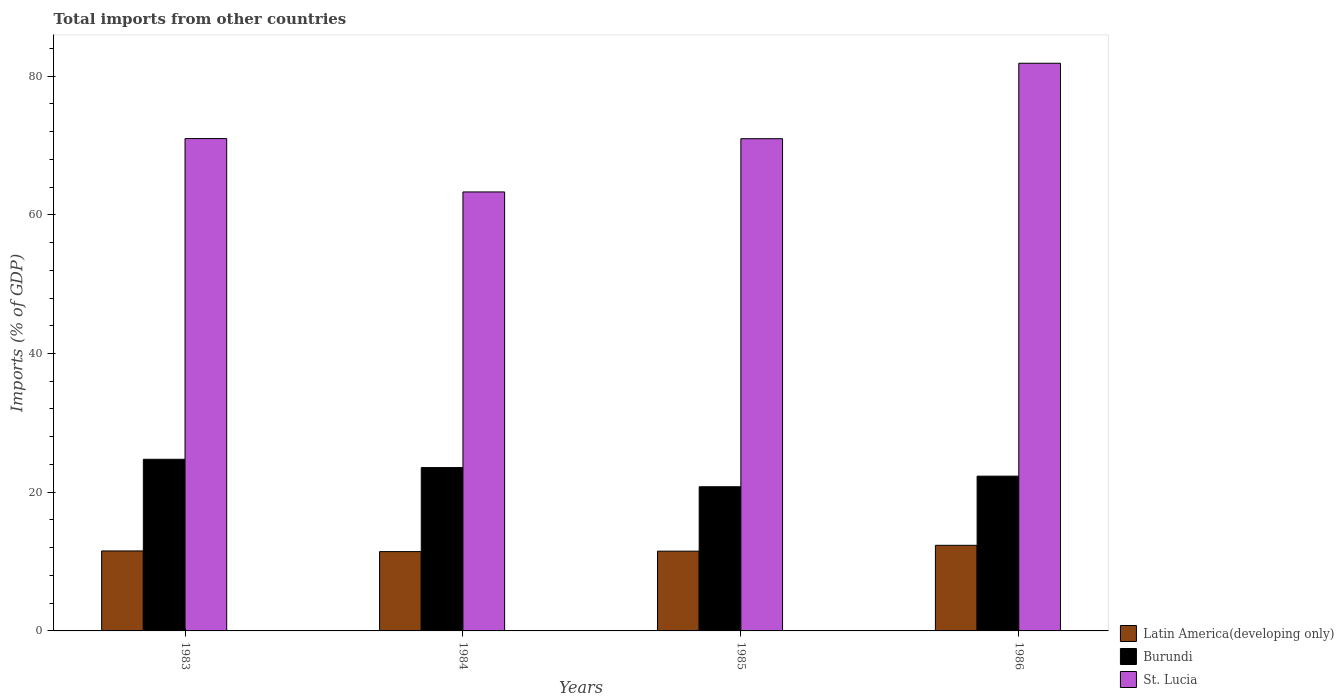Are the number of bars per tick equal to the number of legend labels?
Your answer should be compact. Yes. Are the number of bars on each tick of the X-axis equal?
Provide a succinct answer. Yes. How many bars are there on the 3rd tick from the left?
Provide a short and direct response. 3. In how many cases, is the number of bars for a given year not equal to the number of legend labels?
Ensure brevity in your answer.  0. What is the total imports in Latin America(developing only) in 1984?
Give a very brief answer. 11.44. Across all years, what is the maximum total imports in Burundi?
Your response must be concise. 24.75. Across all years, what is the minimum total imports in St. Lucia?
Ensure brevity in your answer.  63.3. In which year was the total imports in Burundi maximum?
Offer a very short reply. 1983. What is the total total imports in St. Lucia in the graph?
Keep it short and to the point. 287.11. What is the difference between the total imports in Latin America(developing only) in 1983 and that in 1986?
Your answer should be compact. -0.81. What is the difference between the total imports in Latin America(developing only) in 1986 and the total imports in St. Lucia in 1984?
Provide a short and direct response. -50.95. What is the average total imports in Burundi per year?
Keep it short and to the point. 22.85. In the year 1983, what is the difference between the total imports in Burundi and total imports in Latin America(developing only)?
Provide a succinct answer. 13.22. What is the ratio of the total imports in St. Lucia in 1984 to that in 1985?
Your answer should be very brief. 0.89. What is the difference between the highest and the second highest total imports in Burundi?
Provide a short and direct response. 1.2. What is the difference between the highest and the lowest total imports in Latin America(developing only)?
Keep it short and to the point. 0.91. In how many years, is the total imports in Latin America(developing only) greater than the average total imports in Latin America(developing only) taken over all years?
Your answer should be compact. 1. Is the sum of the total imports in Burundi in 1983 and 1986 greater than the maximum total imports in St. Lucia across all years?
Your response must be concise. No. What does the 2nd bar from the left in 1983 represents?
Your answer should be very brief. Burundi. What does the 3rd bar from the right in 1984 represents?
Provide a short and direct response. Latin America(developing only). Is it the case that in every year, the sum of the total imports in Latin America(developing only) and total imports in Burundi is greater than the total imports in St. Lucia?
Your answer should be compact. No. How many bars are there?
Keep it short and to the point. 12. Does the graph contain any zero values?
Your answer should be compact. No. Does the graph contain grids?
Provide a short and direct response. No. How many legend labels are there?
Offer a very short reply. 3. What is the title of the graph?
Offer a very short reply. Total imports from other countries. What is the label or title of the X-axis?
Ensure brevity in your answer.  Years. What is the label or title of the Y-axis?
Provide a short and direct response. Imports (% of GDP). What is the Imports (% of GDP) in Latin America(developing only) in 1983?
Your answer should be very brief. 11.53. What is the Imports (% of GDP) of Burundi in 1983?
Ensure brevity in your answer.  24.75. What is the Imports (% of GDP) in St. Lucia in 1983?
Offer a terse response. 70.99. What is the Imports (% of GDP) in Latin America(developing only) in 1984?
Provide a succinct answer. 11.44. What is the Imports (% of GDP) in Burundi in 1984?
Provide a short and direct response. 23.55. What is the Imports (% of GDP) in St. Lucia in 1984?
Your answer should be compact. 63.3. What is the Imports (% of GDP) of Latin America(developing only) in 1985?
Your response must be concise. 11.5. What is the Imports (% of GDP) in Burundi in 1985?
Provide a short and direct response. 20.79. What is the Imports (% of GDP) of St. Lucia in 1985?
Offer a very short reply. 70.97. What is the Imports (% of GDP) in Latin America(developing only) in 1986?
Provide a short and direct response. 12.34. What is the Imports (% of GDP) in Burundi in 1986?
Ensure brevity in your answer.  22.32. What is the Imports (% of GDP) of St. Lucia in 1986?
Ensure brevity in your answer.  81.85. Across all years, what is the maximum Imports (% of GDP) of Latin America(developing only)?
Provide a short and direct response. 12.34. Across all years, what is the maximum Imports (% of GDP) of Burundi?
Provide a short and direct response. 24.75. Across all years, what is the maximum Imports (% of GDP) of St. Lucia?
Offer a terse response. 81.85. Across all years, what is the minimum Imports (% of GDP) in Latin America(developing only)?
Your answer should be very brief. 11.44. Across all years, what is the minimum Imports (% of GDP) of Burundi?
Your answer should be very brief. 20.79. Across all years, what is the minimum Imports (% of GDP) of St. Lucia?
Provide a short and direct response. 63.3. What is the total Imports (% of GDP) of Latin America(developing only) in the graph?
Your response must be concise. 46.81. What is the total Imports (% of GDP) of Burundi in the graph?
Provide a short and direct response. 91.4. What is the total Imports (% of GDP) of St. Lucia in the graph?
Offer a terse response. 287.11. What is the difference between the Imports (% of GDP) of Latin America(developing only) in 1983 and that in 1984?
Your answer should be very brief. 0.1. What is the difference between the Imports (% of GDP) of Burundi in 1983 and that in 1984?
Your response must be concise. 1.2. What is the difference between the Imports (% of GDP) of St. Lucia in 1983 and that in 1984?
Your answer should be very brief. 7.7. What is the difference between the Imports (% of GDP) of Latin America(developing only) in 1983 and that in 1985?
Your answer should be compact. 0.03. What is the difference between the Imports (% of GDP) of Burundi in 1983 and that in 1985?
Offer a very short reply. 3.96. What is the difference between the Imports (% of GDP) of St. Lucia in 1983 and that in 1985?
Your answer should be very brief. 0.02. What is the difference between the Imports (% of GDP) of Latin America(developing only) in 1983 and that in 1986?
Your answer should be compact. -0.81. What is the difference between the Imports (% of GDP) in Burundi in 1983 and that in 1986?
Your answer should be compact. 2.43. What is the difference between the Imports (% of GDP) of St. Lucia in 1983 and that in 1986?
Your answer should be very brief. -10.86. What is the difference between the Imports (% of GDP) of Latin America(developing only) in 1984 and that in 1985?
Your response must be concise. -0.06. What is the difference between the Imports (% of GDP) of Burundi in 1984 and that in 1985?
Make the answer very short. 2.77. What is the difference between the Imports (% of GDP) of St. Lucia in 1984 and that in 1985?
Keep it short and to the point. -7.68. What is the difference between the Imports (% of GDP) in Latin America(developing only) in 1984 and that in 1986?
Make the answer very short. -0.91. What is the difference between the Imports (% of GDP) of Burundi in 1984 and that in 1986?
Offer a very short reply. 1.24. What is the difference between the Imports (% of GDP) in St. Lucia in 1984 and that in 1986?
Offer a very short reply. -18.55. What is the difference between the Imports (% of GDP) of Latin America(developing only) in 1985 and that in 1986?
Your answer should be compact. -0.84. What is the difference between the Imports (% of GDP) in Burundi in 1985 and that in 1986?
Offer a terse response. -1.53. What is the difference between the Imports (% of GDP) in St. Lucia in 1985 and that in 1986?
Offer a very short reply. -10.88. What is the difference between the Imports (% of GDP) of Latin America(developing only) in 1983 and the Imports (% of GDP) of Burundi in 1984?
Keep it short and to the point. -12.02. What is the difference between the Imports (% of GDP) of Latin America(developing only) in 1983 and the Imports (% of GDP) of St. Lucia in 1984?
Keep it short and to the point. -51.76. What is the difference between the Imports (% of GDP) of Burundi in 1983 and the Imports (% of GDP) of St. Lucia in 1984?
Your answer should be very brief. -38.55. What is the difference between the Imports (% of GDP) of Latin America(developing only) in 1983 and the Imports (% of GDP) of Burundi in 1985?
Keep it short and to the point. -9.25. What is the difference between the Imports (% of GDP) in Latin America(developing only) in 1983 and the Imports (% of GDP) in St. Lucia in 1985?
Make the answer very short. -59.44. What is the difference between the Imports (% of GDP) in Burundi in 1983 and the Imports (% of GDP) in St. Lucia in 1985?
Make the answer very short. -46.23. What is the difference between the Imports (% of GDP) in Latin America(developing only) in 1983 and the Imports (% of GDP) in Burundi in 1986?
Offer a terse response. -10.78. What is the difference between the Imports (% of GDP) in Latin America(developing only) in 1983 and the Imports (% of GDP) in St. Lucia in 1986?
Offer a very short reply. -70.32. What is the difference between the Imports (% of GDP) of Burundi in 1983 and the Imports (% of GDP) of St. Lucia in 1986?
Make the answer very short. -57.1. What is the difference between the Imports (% of GDP) of Latin America(developing only) in 1984 and the Imports (% of GDP) of Burundi in 1985?
Give a very brief answer. -9.35. What is the difference between the Imports (% of GDP) in Latin America(developing only) in 1984 and the Imports (% of GDP) in St. Lucia in 1985?
Your answer should be compact. -59.54. What is the difference between the Imports (% of GDP) of Burundi in 1984 and the Imports (% of GDP) of St. Lucia in 1985?
Offer a very short reply. -47.42. What is the difference between the Imports (% of GDP) in Latin America(developing only) in 1984 and the Imports (% of GDP) in Burundi in 1986?
Your answer should be compact. -10.88. What is the difference between the Imports (% of GDP) of Latin America(developing only) in 1984 and the Imports (% of GDP) of St. Lucia in 1986?
Provide a short and direct response. -70.41. What is the difference between the Imports (% of GDP) of Burundi in 1984 and the Imports (% of GDP) of St. Lucia in 1986?
Provide a short and direct response. -58.3. What is the difference between the Imports (% of GDP) in Latin America(developing only) in 1985 and the Imports (% of GDP) in Burundi in 1986?
Keep it short and to the point. -10.81. What is the difference between the Imports (% of GDP) of Latin America(developing only) in 1985 and the Imports (% of GDP) of St. Lucia in 1986?
Your answer should be compact. -70.35. What is the difference between the Imports (% of GDP) of Burundi in 1985 and the Imports (% of GDP) of St. Lucia in 1986?
Provide a short and direct response. -61.06. What is the average Imports (% of GDP) of Latin America(developing only) per year?
Offer a terse response. 11.7. What is the average Imports (% of GDP) in Burundi per year?
Provide a short and direct response. 22.85. What is the average Imports (% of GDP) in St. Lucia per year?
Provide a succinct answer. 71.78. In the year 1983, what is the difference between the Imports (% of GDP) in Latin America(developing only) and Imports (% of GDP) in Burundi?
Offer a very short reply. -13.22. In the year 1983, what is the difference between the Imports (% of GDP) in Latin America(developing only) and Imports (% of GDP) in St. Lucia?
Keep it short and to the point. -59.46. In the year 1983, what is the difference between the Imports (% of GDP) of Burundi and Imports (% of GDP) of St. Lucia?
Provide a succinct answer. -46.24. In the year 1984, what is the difference between the Imports (% of GDP) of Latin America(developing only) and Imports (% of GDP) of Burundi?
Give a very brief answer. -12.12. In the year 1984, what is the difference between the Imports (% of GDP) in Latin America(developing only) and Imports (% of GDP) in St. Lucia?
Provide a succinct answer. -51.86. In the year 1984, what is the difference between the Imports (% of GDP) of Burundi and Imports (% of GDP) of St. Lucia?
Ensure brevity in your answer.  -39.74. In the year 1985, what is the difference between the Imports (% of GDP) of Latin America(developing only) and Imports (% of GDP) of Burundi?
Keep it short and to the point. -9.29. In the year 1985, what is the difference between the Imports (% of GDP) of Latin America(developing only) and Imports (% of GDP) of St. Lucia?
Provide a succinct answer. -59.47. In the year 1985, what is the difference between the Imports (% of GDP) in Burundi and Imports (% of GDP) in St. Lucia?
Provide a succinct answer. -50.19. In the year 1986, what is the difference between the Imports (% of GDP) in Latin America(developing only) and Imports (% of GDP) in Burundi?
Give a very brief answer. -9.97. In the year 1986, what is the difference between the Imports (% of GDP) of Latin America(developing only) and Imports (% of GDP) of St. Lucia?
Keep it short and to the point. -69.51. In the year 1986, what is the difference between the Imports (% of GDP) in Burundi and Imports (% of GDP) in St. Lucia?
Make the answer very short. -59.53. What is the ratio of the Imports (% of GDP) in Latin America(developing only) in 1983 to that in 1984?
Your answer should be very brief. 1.01. What is the ratio of the Imports (% of GDP) in Burundi in 1983 to that in 1984?
Provide a succinct answer. 1.05. What is the ratio of the Imports (% of GDP) in St. Lucia in 1983 to that in 1984?
Provide a short and direct response. 1.12. What is the ratio of the Imports (% of GDP) of Burundi in 1983 to that in 1985?
Offer a terse response. 1.19. What is the ratio of the Imports (% of GDP) in Latin America(developing only) in 1983 to that in 1986?
Ensure brevity in your answer.  0.93. What is the ratio of the Imports (% of GDP) of Burundi in 1983 to that in 1986?
Keep it short and to the point. 1.11. What is the ratio of the Imports (% of GDP) in St. Lucia in 1983 to that in 1986?
Make the answer very short. 0.87. What is the ratio of the Imports (% of GDP) of Latin America(developing only) in 1984 to that in 1985?
Your answer should be very brief. 0.99. What is the ratio of the Imports (% of GDP) in Burundi in 1984 to that in 1985?
Your response must be concise. 1.13. What is the ratio of the Imports (% of GDP) in St. Lucia in 1984 to that in 1985?
Offer a very short reply. 0.89. What is the ratio of the Imports (% of GDP) in Latin America(developing only) in 1984 to that in 1986?
Keep it short and to the point. 0.93. What is the ratio of the Imports (% of GDP) of Burundi in 1984 to that in 1986?
Provide a succinct answer. 1.06. What is the ratio of the Imports (% of GDP) in St. Lucia in 1984 to that in 1986?
Offer a terse response. 0.77. What is the ratio of the Imports (% of GDP) of Latin America(developing only) in 1985 to that in 1986?
Your response must be concise. 0.93. What is the ratio of the Imports (% of GDP) of Burundi in 1985 to that in 1986?
Give a very brief answer. 0.93. What is the ratio of the Imports (% of GDP) of St. Lucia in 1985 to that in 1986?
Offer a very short reply. 0.87. What is the difference between the highest and the second highest Imports (% of GDP) in Latin America(developing only)?
Offer a terse response. 0.81. What is the difference between the highest and the second highest Imports (% of GDP) of Burundi?
Your response must be concise. 1.2. What is the difference between the highest and the second highest Imports (% of GDP) in St. Lucia?
Provide a short and direct response. 10.86. What is the difference between the highest and the lowest Imports (% of GDP) of Latin America(developing only)?
Offer a terse response. 0.91. What is the difference between the highest and the lowest Imports (% of GDP) of Burundi?
Make the answer very short. 3.96. What is the difference between the highest and the lowest Imports (% of GDP) in St. Lucia?
Your answer should be very brief. 18.55. 